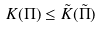Convert formula to latex. <formula><loc_0><loc_0><loc_500><loc_500>K ( \Pi ) \leq \tilde { K } ( \tilde { \Pi } )</formula> 